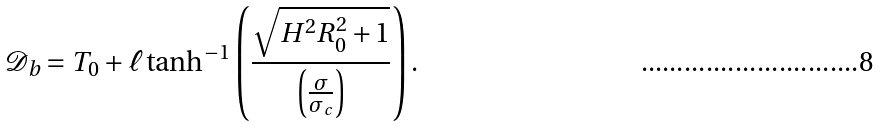<formula> <loc_0><loc_0><loc_500><loc_500>\mathcal { D } _ { b } = T _ { 0 } + \ell \tanh ^ { - 1 } \left ( \frac { \sqrt { H ^ { 2 } R _ { 0 } ^ { 2 } + 1 } } { \left ( \frac { \sigma } { \sigma _ { c } } \right ) } \right ) .</formula> 